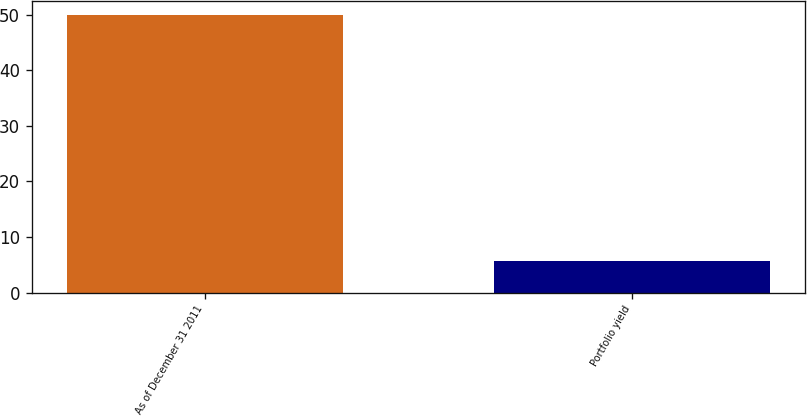Convert chart to OTSL. <chart><loc_0><loc_0><loc_500><loc_500><bar_chart><fcel>As of December 31 2011<fcel>Portfolio yield<nl><fcel>50<fcel>5.68<nl></chart> 